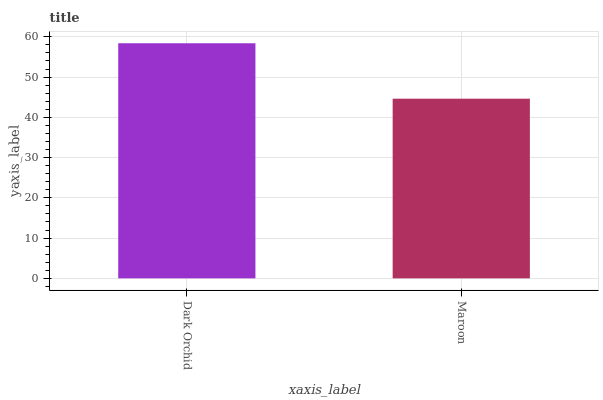Is Maroon the maximum?
Answer yes or no. No. Is Dark Orchid greater than Maroon?
Answer yes or no. Yes. Is Maroon less than Dark Orchid?
Answer yes or no. Yes. Is Maroon greater than Dark Orchid?
Answer yes or no. No. Is Dark Orchid less than Maroon?
Answer yes or no. No. Is Dark Orchid the high median?
Answer yes or no. Yes. Is Maroon the low median?
Answer yes or no. Yes. Is Maroon the high median?
Answer yes or no. No. Is Dark Orchid the low median?
Answer yes or no. No. 